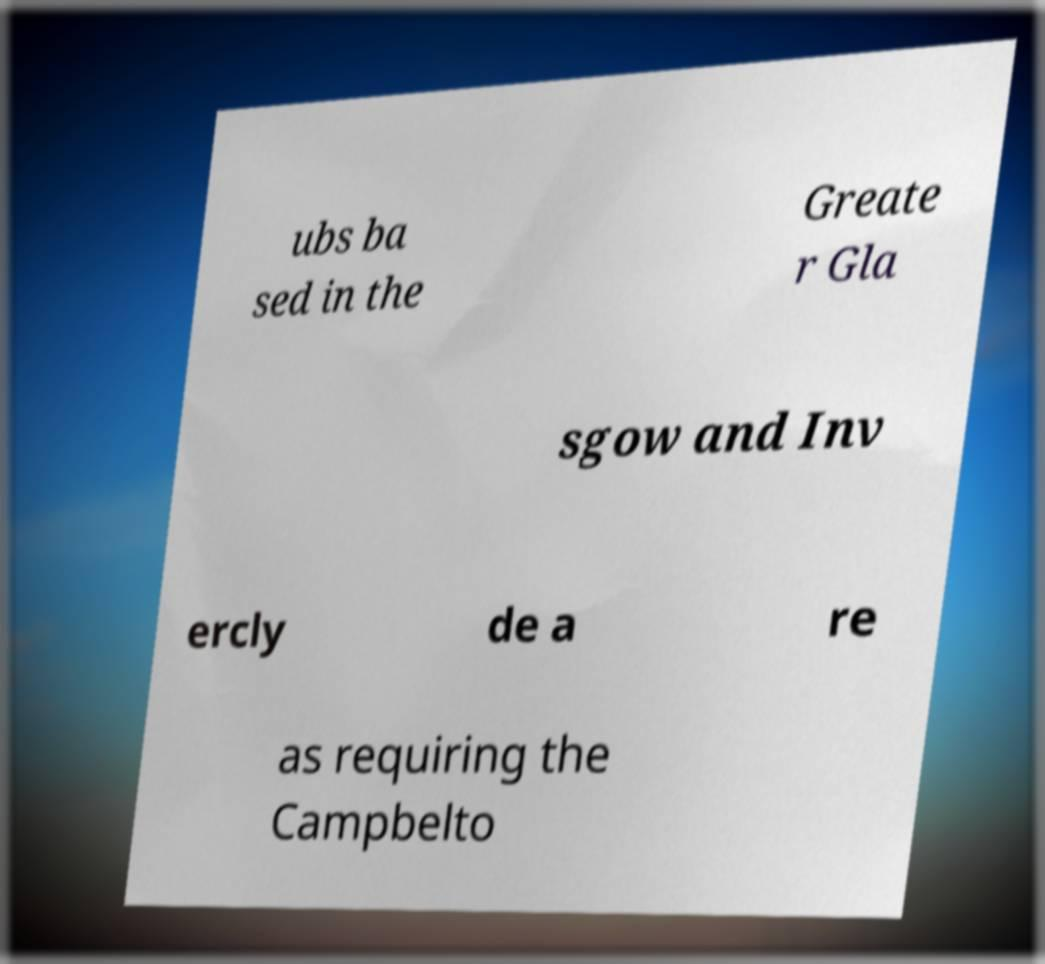Please read and relay the text visible in this image. What does it say? ubs ba sed in the Greate r Gla sgow and Inv ercly de a re as requiring the Campbelto 